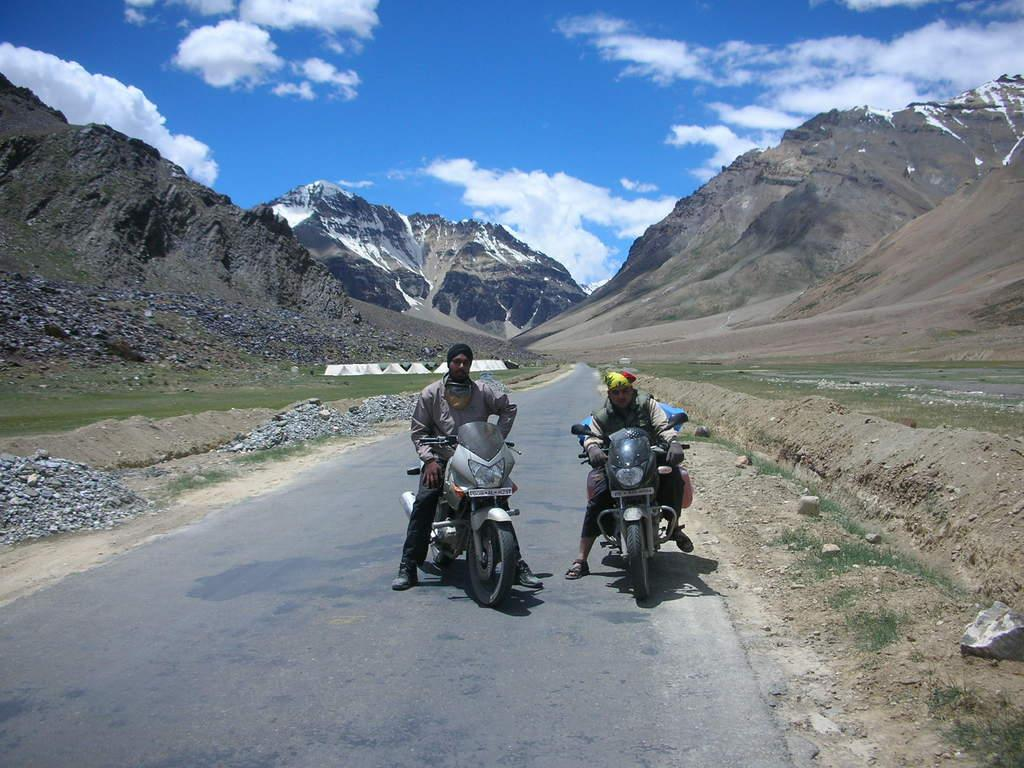What is the main feature of the image? There is a road in the image. Can you describe the people in the image? There are two people in the image, and they are riding bikes. What can be seen in the background of the image? There are mountains and a clear sky visible in the background of the image. What type of story is being told in the image? There is no story being told in the image; it is a visual representation of a road, two people riding bikes, and the background. 